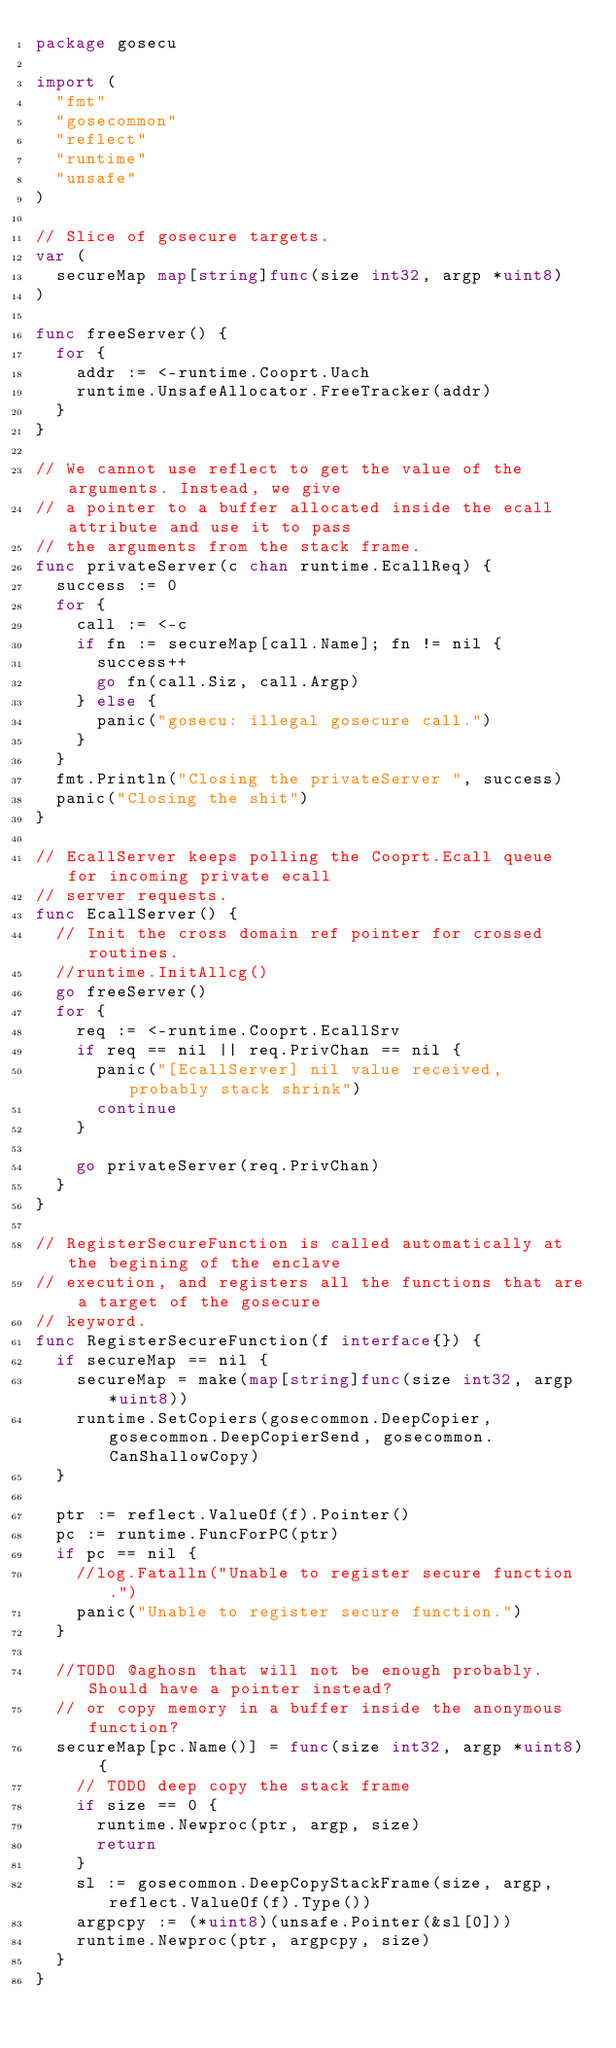Convert code to text. <code><loc_0><loc_0><loc_500><loc_500><_Go_>package gosecu

import (
	"fmt"
	"gosecommon"
	"reflect"
	"runtime"
	"unsafe"
)

// Slice of gosecure targets.
var (
	secureMap map[string]func(size int32, argp *uint8)
)

func freeServer() {
	for {
		addr := <-runtime.Cooprt.Uach
		runtime.UnsafeAllocator.FreeTracker(addr)
	}
}

// We cannot use reflect to get the value of the arguments. Instead, we give
// a pointer to a buffer allocated inside the ecall attribute and use it to pass
// the arguments from the stack frame.
func privateServer(c chan runtime.EcallReq) {
	success := 0
	for {
		call := <-c
		if fn := secureMap[call.Name]; fn != nil {
			success++
			go fn(call.Siz, call.Argp)
		} else {
			panic("gosecu: illegal gosecure call.")
		}
	}
	fmt.Println("Closing the privateServer ", success)
	panic("Closing the shit")
}

// EcallServer keeps polling the Cooprt.Ecall queue for incoming private ecall
// server requests.
func EcallServer() {
	// Init the cross domain ref pointer for crossed routines.
	//runtime.InitAllcg()
	go freeServer()
	for {
		req := <-runtime.Cooprt.EcallSrv
		if req == nil || req.PrivChan == nil {
			panic("[EcallServer] nil value received, probably stack shrink")
			continue
		}

		go privateServer(req.PrivChan)
	}
}

// RegisterSecureFunction is called automatically at the begining of the enclave
// execution, and registers all the functions that are a target of the gosecure
// keyword.
func RegisterSecureFunction(f interface{}) {
	if secureMap == nil {
		secureMap = make(map[string]func(size int32, argp *uint8))
		runtime.SetCopiers(gosecommon.DeepCopier, gosecommon.DeepCopierSend, gosecommon.CanShallowCopy)
	}

	ptr := reflect.ValueOf(f).Pointer()
	pc := runtime.FuncForPC(ptr)
	if pc == nil {
		//log.Fatalln("Unable to register secure function.")
		panic("Unable to register secure function.")
	}

	//TODO @aghosn that will not be enough probably. Should have a pointer instead?
	// or copy memory in a buffer inside the anonymous function?
	secureMap[pc.Name()] = func(size int32, argp *uint8) {
		// TODO deep copy the stack frame
		if size == 0 {
			runtime.Newproc(ptr, argp, size)
			return
		}
		sl := gosecommon.DeepCopyStackFrame(size, argp, reflect.ValueOf(f).Type())
		argpcpy := (*uint8)(unsafe.Pointer(&sl[0]))
		runtime.Newproc(ptr, argpcpy, size)
	}
}
</code> 